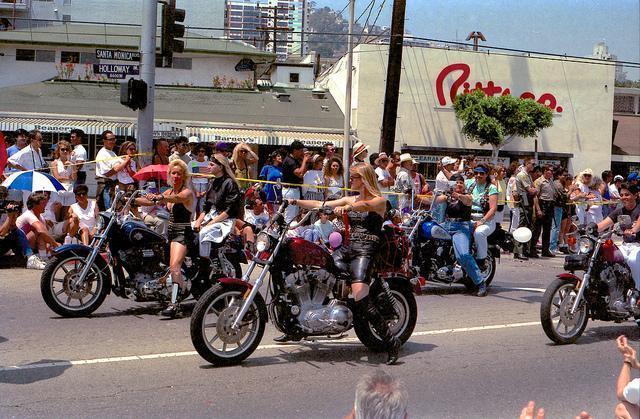How many motorcycles on the street?
Give a very brief answer. 4. How many motorcycles are in the picture?
Give a very brief answer. 4. How many people are in the picture?
Give a very brief answer. 6. 